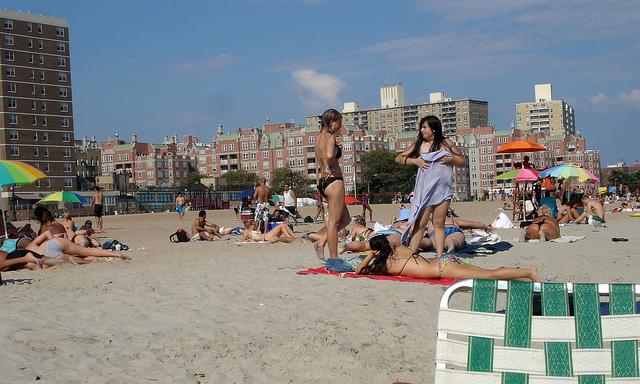Only one umbrella in this picture is a solid color; what color is it?
Be succinct. Orange. Are there clouds?
Answer briefly. Yes. How many umbrellas are there?
Be succinct. 5. Where are these people relaxing?
Quick response, please. Beach. What color is the umbrellas?
Quick response, please. Rainbow. 